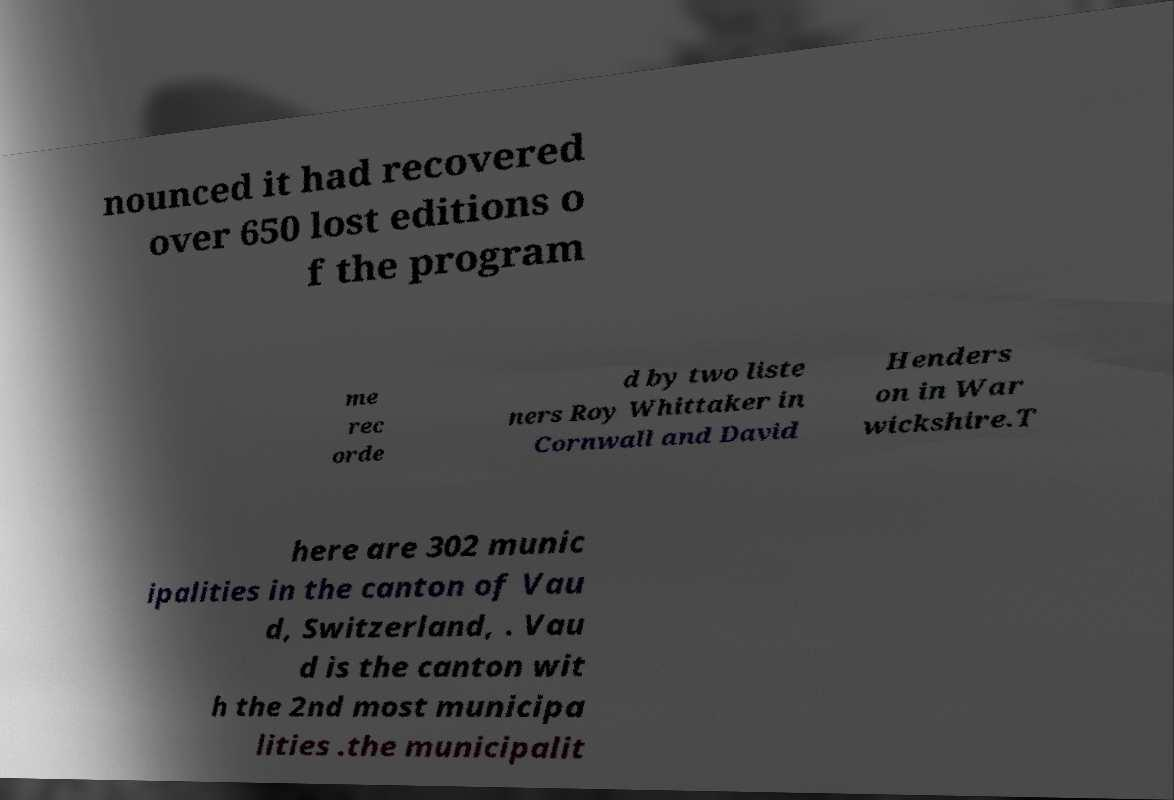Can you read and provide the text displayed in the image?This photo seems to have some interesting text. Can you extract and type it out for me? nounced it had recovered over 650 lost editions o f the program me rec orde d by two liste ners Roy Whittaker in Cornwall and David Henders on in War wickshire.T here are 302 munic ipalities in the canton of Vau d, Switzerland, . Vau d is the canton wit h the 2nd most municipa lities .the municipalit 